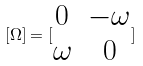<formula> <loc_0><loc_0><loc_500><loc_500>[ \Omega ] = [ \begin{matrix} 0 & - \omega \\ \omega & 0 \end{matrix} ]</formula> 